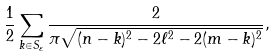<formula> <loc_0><loc_0><loc_500><loc_500>\frac { 1 } { 2 } \sum _ { k \in S _ { \varepsilon } } { \frac { 2 } { \pi \sqrt { ( n - k ) ^ { 2 } - 2 \ell ^ { 2 } - 2 ( m - k ) ^ { 2 } } } } ,</formula> 